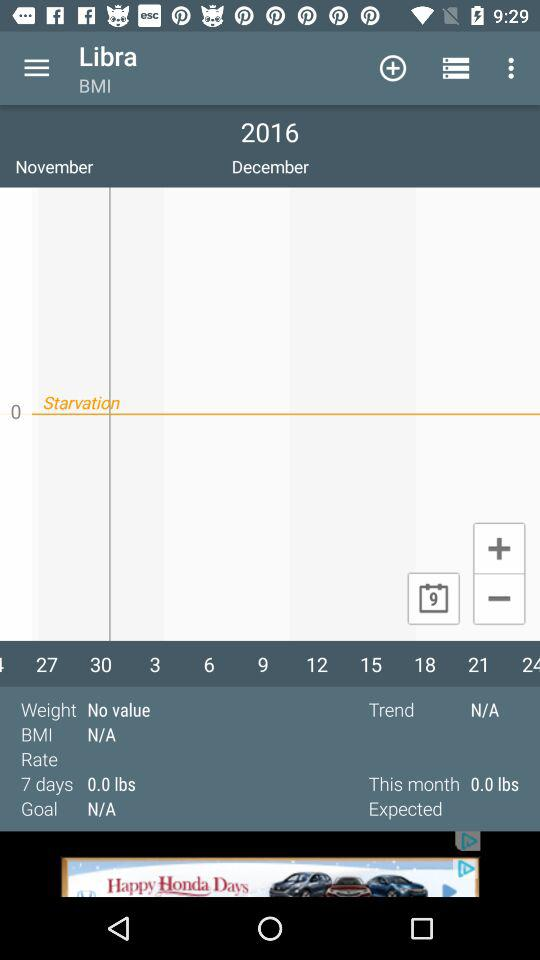What is the expected weight loss for this month?
Answer the question using a single word or phrase. 0.0 lbs 